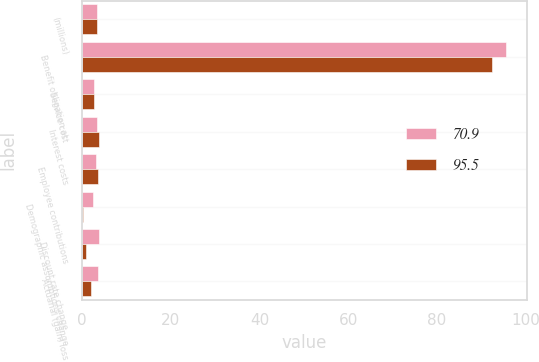<chart> <loc_0><loc_0><loc_500><loc_500><stacked_bar_chart><ecel><fcel>(millions)<fcel>Benefit obligation at<fcel>Service cost<fcel>Interest costs<fcel>Employee contributions<fcel>Demographic assumptions change<fcel>Discount rate change<fcel>Actuarial (gain) loss<nl><fcel>70.9<fcel>3.25<fcel>95.5<fcel>2.6<fcel>3.3<fcel>3.2<fcel>2.4<fcel>3.7<fcel>3.5<nl><fcel>95.5<fcel>3.25<fcel>92.4<fcel>2.7<fcel>3.8<fcel>3.6<fcel>0.2<fcel>0.8<fcel>2<nl></chart> 